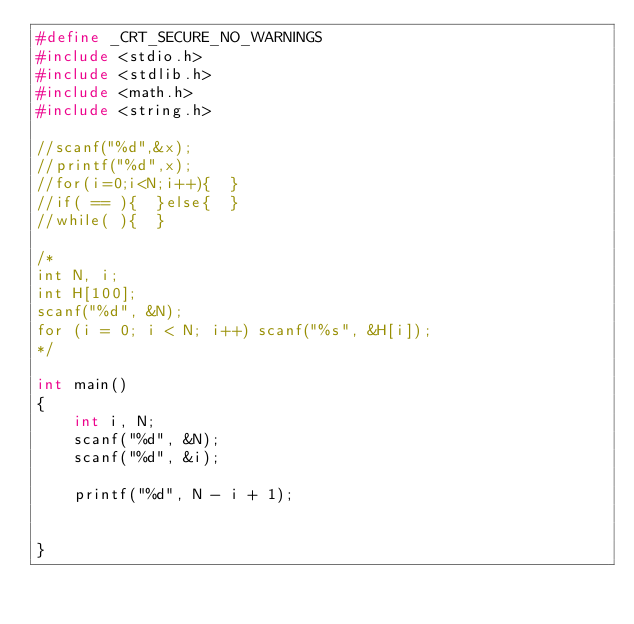Convert code to text. <code><loc_0><loc_0><loc_500><loc_500><_C_>#define _CRT_SECURE_NO_WARNINGS
#include <stdio.h>
#include <stdlib.h>
#include <math.h>
#include <string.h>

//scanf("%d",&x);
//printf("%d",x);
//for(i=0;i<N;i++){  }
//if( == ){  }else{  }
//while( ){  }

/*
int N, i;
int H[100];
scanf("%d", &N);
for (i = 0; i < N; i++) scanf("%s", &H[i]);
*/

int main()
{
	int i, N;
	scanf("%d", &N);
	scanf("%d", &i);

	printf("%d", N - i + 1);
	

}</code> 